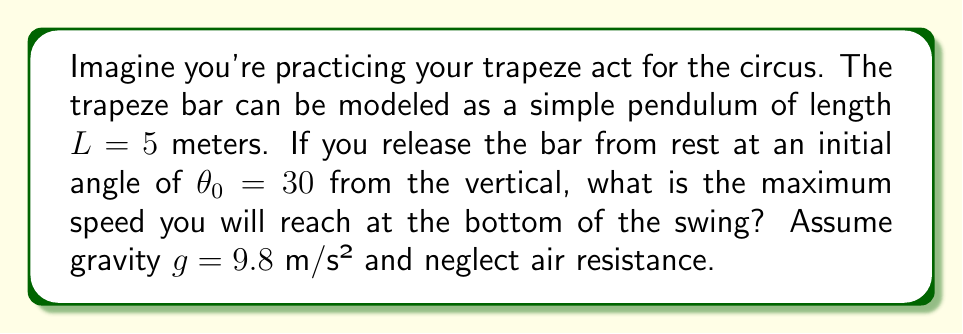Teach me how to tackle this problem. Let's approach this step-by-step:

1) The motion of a simple pendulum can be described using the principle of conservation of energy. At any point in the swing, the sum of potential energy and kinetic energy remains constant.

2) At the initial position:
   - Potential energy: $PE_i = mgH = mgL(1-\cos\theta_0)$
   - Kinetic energy: $KE_i = 0$ (released from rest)

3) At the bottom of the swing:
   - Potential energy: $PE_f = 0$
   - Kinetic energy: $KE_f = \frac{1}{2}mv^2$

4) By conservation of energy:
   $PE_i + KE_i = PE_f + KE_f$
   $mgL(1-\cos\theta_0) + 0 = 0 + \frac{1}{2}mv^2$

5) Solving for $v$:
   $v = \sqrt{2gL(1-\cos\theta_0)}$

6) Now, let's plug in our values:
   $L = 5$ m
   $g = 9.8$ m/s²
   $\theta_0 = 30° = \frac{\pi}{6}$ radians

   $v = \sqrt{2 \cdot 9.8 \cdot 5 \cdot (1-\cos\frac{\pi}{6})}$

7) Simplify:
   $v = \sqrt{98 \cdot (1-\frac{\sqrt{3}}{2})}$
   $v \approx 4.85$ m/s

Thus, the maximum speed reached at the bottom of the swing is approximately 4.85 m/s.
Answer: 4.85 m/s 